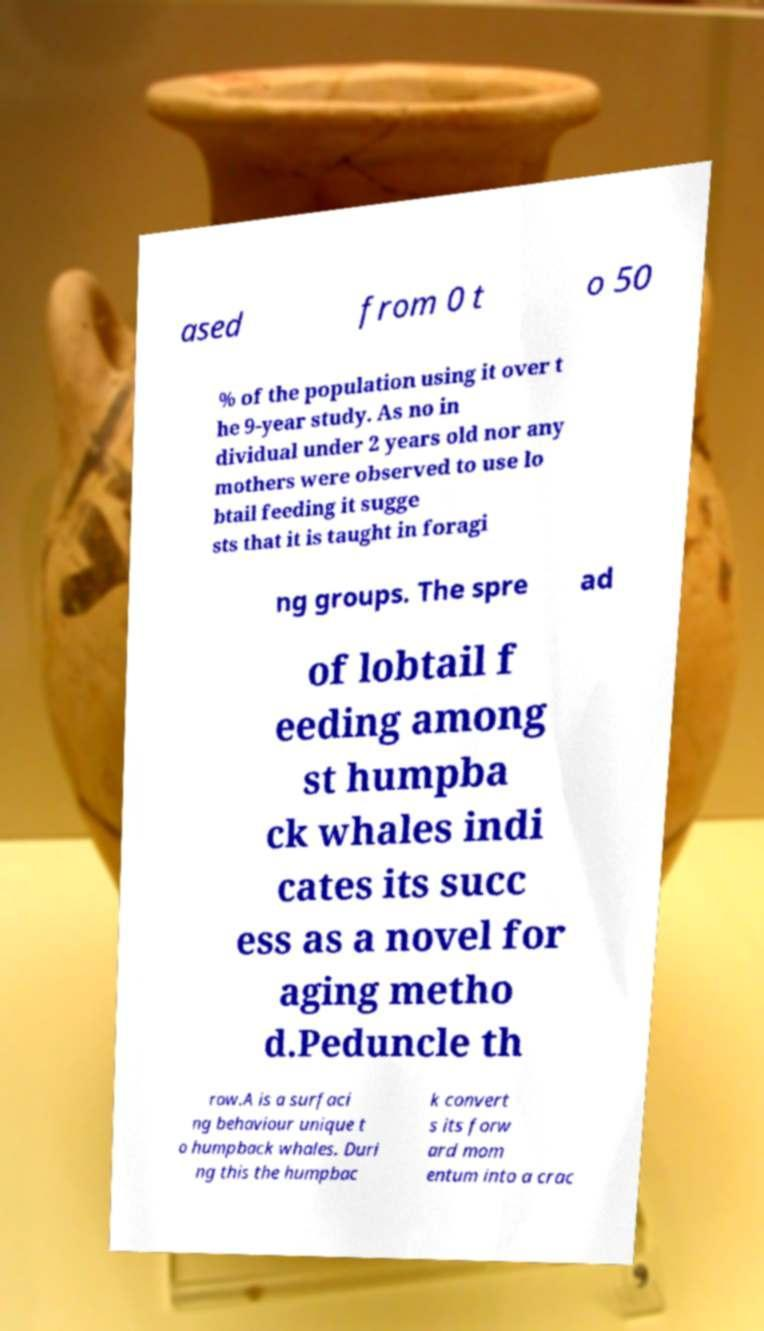Can you read and provide the text displayed in the image?This photo seems to have some interesting text. Can you extract and type it out for me? ased from 0 t o 50 % of the population using it over t he 9-year study. As no in dividual under 2 years old nor any mothers were observed to use lo btail feeding it sugge sts that it is taught in foragi ng groups. The spre ad of lobtail f eeding among st humpba ck whales indi cates its succ ess as a novel for aging metho d.Peduncle th row.A is a surfaci ng behaviour unique t o humpback whales. Duri ng this the humpbac k convert s its forw ard mom entum into a crac 